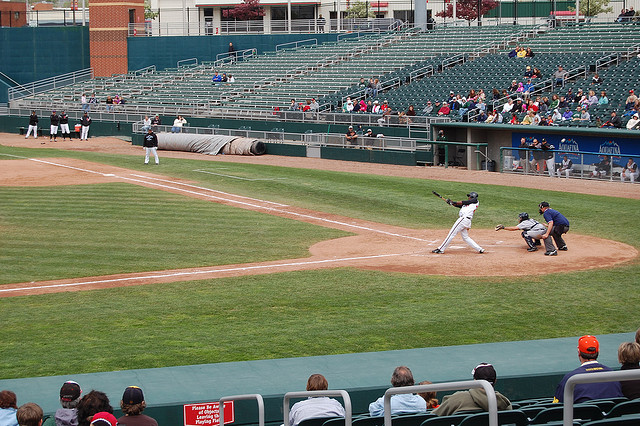Do you think the batter might hit a home run? It’s hard to predict from just a single image whether the batter will hit a home run. Based on the posture and the swing in the image, it seems like a powerful attempt, but hitting a home run depends on several factors like the pitch, the batter's strength and timing, and even the ballpark dimensions. Imagine if a dragon were to appear in the middle of this game. How would the players and spectators react? That would be quite a wild and imaginative event! If a dragon were to appear in the middle of the game, the initial reaction would likely be one of shock and fear. Players might scatter from the field, trying to find safety. Spectators might flee the stands in a panic or gawk in awe and disbelief. The game would obviously come to a halt as everyone tries to comprehend what is happening. Depending on the nature of the dragon, if it were friendly, there could even be some extraordinary and memorable interactions between the mythical creature and humans! 